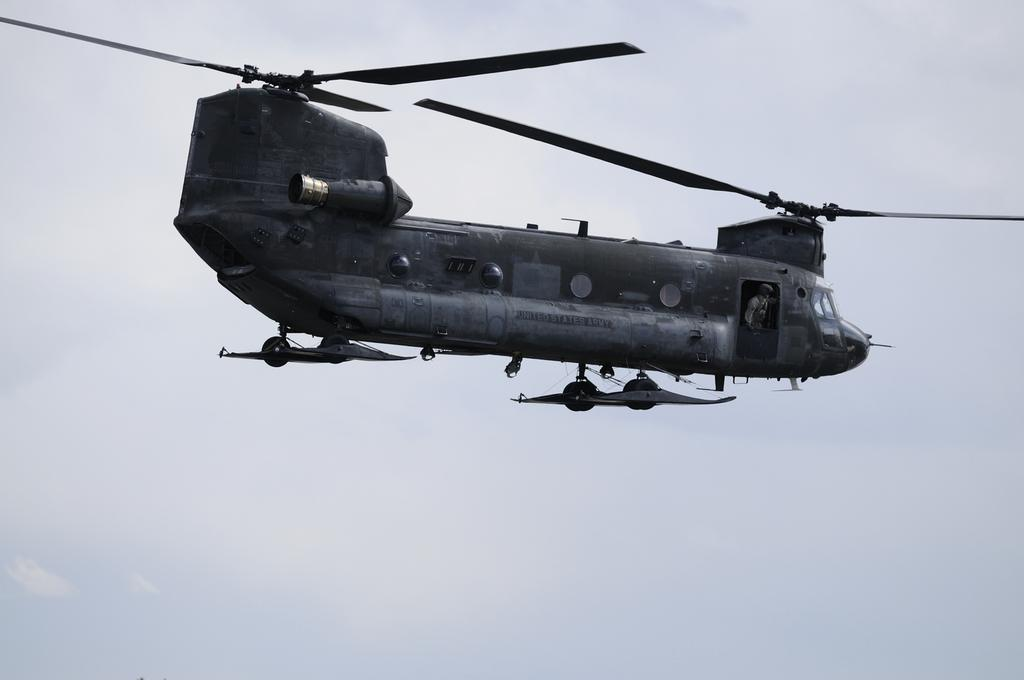What is the main subject of the image? The main subject of the image is a helicopter. How is the helicopter positioned in the image? The helicopter is in front of other elements in the image. What can be seen in the background of the image? The sky is visible in the background of the image. What type of thought can be seen in the image? There are no thoughts visible in the image; it features a helicopter in front of other elements with the sky in the background. What material is the stamp made of in the image? There is no stamp present in the image. 